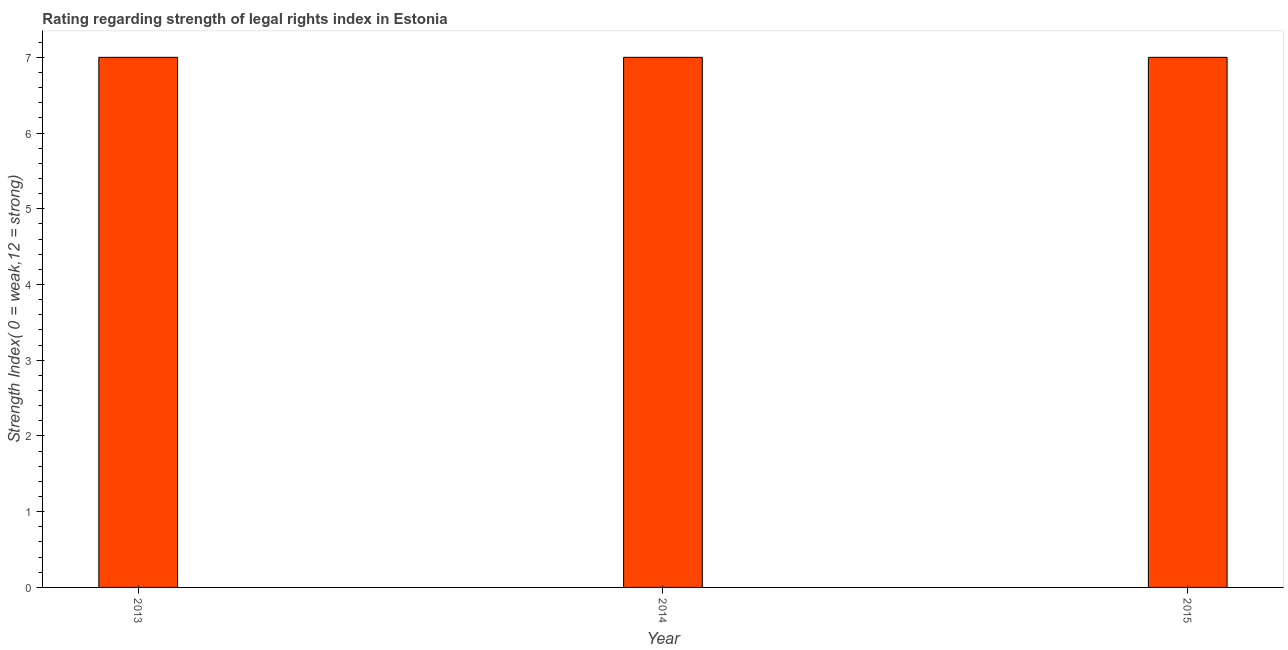What is the title of the graph?
Your answer should be very brief. Rating regarding strength of legal rights index in Estonia. What is the label or title of the X-axis?
Your answer should be compact. Year. What is the label or title of the Y-axis?
Your response must be concise. Strength Index( 0 = weak,12 = strong). What is the strength of legal rights index in 2014?
Your answer should be compact. 7. Across all years, what is the minimum strength of legal rights index?
Your response must be concise. 7. In which year was the strength of legal rights index maximum?
Offer a terse response. 2013. In which year was the strength of legal rights index minimum?
Your answer should be very brief. 2013. What is the sum of the strength of legal rights index?
Offer a terse response. 21. What is the difference between the strength of legal rights index in 2013 and 2015?
Make the answer very short. 0. Do a majority of the years between 2014 and 2013 (inclusive) have strength of legal rights index greater than 6.2 ?
Offer a very short reply. No. Is the strength of legal rights index in 2013 less than that in 2014?
Offer a very short reply. No. Is the difference between the strength of legal rights index in 2013 and 2015 greater than the difference between any two years?
Make the answer very short. Yes. What is the difference between the highest and the second highest strength of legal rights index?
Your response must be concise. 0. What is the difference between the highest and the lowest strength of legal rights index?
Offer a very short reply. 0. In how many years, is the strength of legal rights index greater than the average strength of legal rights index taken over all years?
Offer a terse response. 0. How many bars are there?
Your answer should be very brief. 3. Are all the bars in the graph horizontal?
Ensure brevity in your answer.  No. How many years are there in the graph?
Your answer should be very brief. 3. What is the Strength Index( 0 = weak,12 = strong) in 2013?
Give a very brief answer. 7. What is the Strength Index( 0 = weak,12 = strong) in 2014?
Offer a terse response. 7. What is the difference between the Strength Index( 0 = weak,12 = strong) in 2013 and 2014?
Offer a very short reply. 0. What is the difference between the Strength Index( 0 = weak,12 = strong) in 2014 and 2015?
Your answer should be very brief. 0. What is the ratio of the Strength Index( 0 = weak,12 = strong) in 2013 to that in 2014?
Provide a short and direct response. 1. What is the ratio of the Strength Index( 0 = weak,12 = strong) in 2013 to that in 2015?
Your answer should be very brief. 1. What is the ratio of the Strength Index( 0 = weak,12 = strong) in 2014 to that in 2015?
Ensure brevity in your answer.  1. 